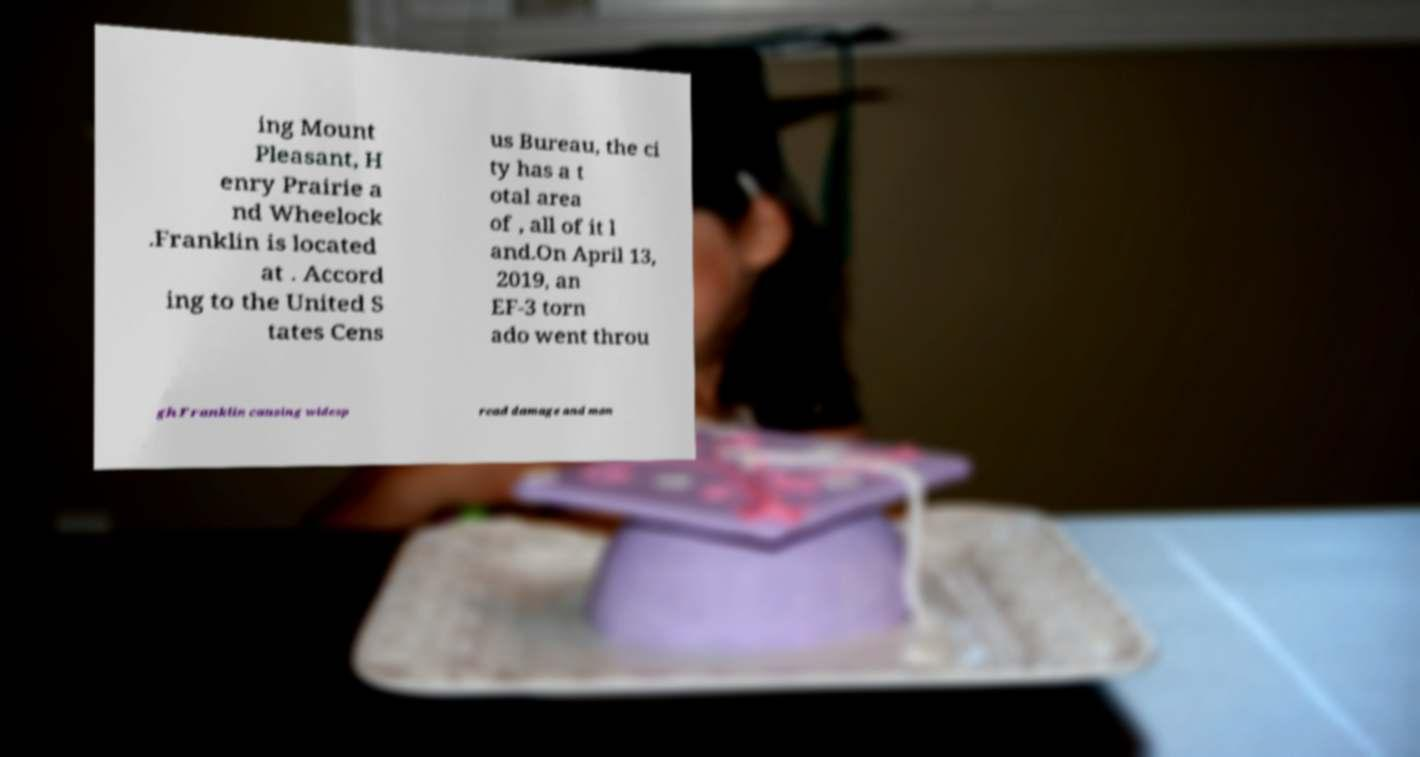Can you read and provide the text displayed in the image?This photo seems to have some interesting text. Can you extract and type it out for me? ing Mount Pleasant, H enry Prairie a nd Wheelock .Franklin is located at . Accord ing to the United S tates Cens us Bureau, the ci ty has a t otal area of , all of it l and.On April 13, 2019, an EF-3 torn ado went throu gh Franklin causing widesp read damage and man 